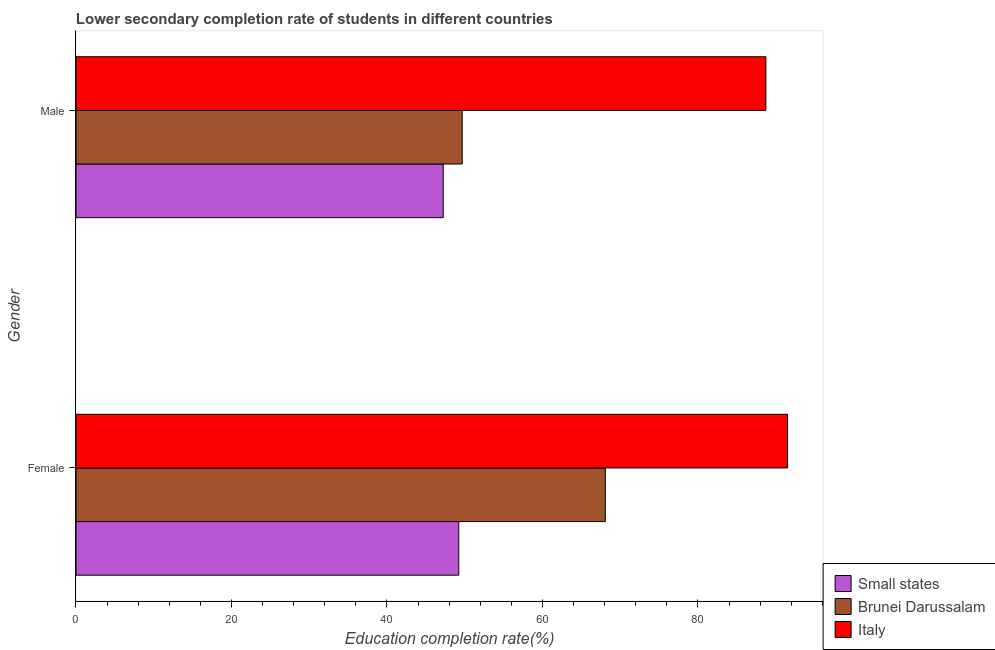How many different coloured bars are there?
Your answer should be very brief. 3. How many groups of bars are there?
Ensure brevity in your answer.  2. Are the number of bars on each tick of the Y-axis equal?
Provide a succinct answer. Yes. What is the education completion rate of female students in Italy?
Provide a short and direct response. 91.52. Across all countries, what is the maximum education completion rate of male students?
Your answer should be compact. 88.74. Across all countries, what is the minimum education completion rate of female students?
Your answer should be very brief. 49.23. In which country was the education completion rate of male students maximum?
Give a very brief answer. Italy. In which country was the education completion rate of female students minimum?
Your answer should be compact. Small states. What is the total education completion rate of female students in the graph?
Provide a succinct answer. 208.84. What is the difference between the education completion rate of male students in Brunei Darussalam and that in Small states?
Provide a short and direct response. 2.44. What is the difference between the education completion rate of male students in Italy and the education completion rate of female students in Small states?
Your answer should be compact. 39.5. What is the average education completion rate of male students per country?
Provide a succinct answer. 61.88. What is the difference between the education completion rate of male students and education completion rate of female students in Brunei Darussalam?
Your response must be concise. -18.41. What is the ratio of the education completion rate of male students in Italy to that in Brunei Darussalam?
Provide a short and direct response. 1.79. In how many countries, is the education completion rate of female students greater than the average education completion rate of female students taken over all countries?
Offer a very short reply. 1. What does the 2nd bar from the top in Male represents?
Offer a very short reply. Brunei Darussalam. What does the 3rd bar from the bottom in Male represents?
Provide a succinct answer. Italy. Are all the bars in the graph horizontal?
Your response must be concise. Yes. How many countries are there in the graph?
Make the answer very short. 3. Does the graph contain any zero values?
Ensure brevity in your answer.  No. Does the graph contain grids?
Ensure brevity in your answer.  No. How many legend labels are there?
Offer a terse response. 3. How are the legend labels stacked?
Make the answer very short. Vertical. What is the title of the graph?
Your answer should be very brief. Lower secondary completion rate of students in different countries. Does "Burundi" appear as one of the legend labels in the graph?
Offer a very short reply. No. What is the label or title of the X-axis?
Your answer should be compact. Education completion rate(%). What is the Education completion rate(%) of Small states in Female?
Provide a succinct answer. 49.23. What is the Education completion rate(%) of Brunei Darussalam in Female?
Keep it short and to the point. 68.08. What is the Education completion rate(%) in Italy in Female?
Your answer should be very brief. 91.52. What is the Education completion rate(%) of Small states in Male?
Offer a very short reply. 47.24. What is the Education completion rate(%) in Brunei Darussalam in Male?
Make the answer very short. 49.68. What is the Education completion rate(%) in Italy in Male?
Ensure brevity in your answer.  88.74. Across all Gender, what is the maximum Education completion rate(%) of Small states?
Offer a terse response. 49.23. Across all Gender, what is the maximum Education completion rate(%) in Brunei Darussalam?
Make the answer very short. 68.08. Across all Gender, what is the maximum Education completion rate(%) in Italy?
Your answer should be compact. 91.52. Across all Gender, what is the minimum Education completion rate(%) in Small states?
Your answer should be very brief. 47.24. Across all Gender, what is the minimum Education completion rate(%) in Brunei Darussalam?
Ensure brevity in your answer.  49.68. Across all Gender, what is the minimum Education completion rate(%) of Italy?
Offer a terse response. 88.74. What is the total Education completion rate(%) of Small states in the graph?
Make the answer very short. 96.47. What is the total Education completion rate(%) of Brunei Darussalam in the graph?
Offer a very short reply. 117.76. What is the total Education completion rate(%) of Italy in the graph?
Offer a terse response. 180.26. What is the difference between the Education completion rate(%) of Small states in Female and that in Male?
Provide a short and direct response. 2. What is the difference between the Education completion rate(%) of Brunei Darussalam in Female and that in Male?
Keep it short and to the point. 18.41. What is the difference between the Education completion rate(%) in Italy in Female and that in Male?
Keep it short and to the point. 2.78. What is the difference between the Education completion rate(%) in Small states in Female and the Education completion rate(%) in Brunei Darussalam in Male?
Provide a short and direct response. -0.44. What is the difference between the Education completion rate(%) of Small states in Female and the Education completion rate(%) of Italy in Male?
Ensure brevity in your answer.  -39.5. What is the difference between the Education completion rate(%) in Brunei Darussalam in Female and the Education completion rate(%) in Italy in Male?
Your answer should be compact. -20.65. What is the average Education completion rate(%) in Small states per Gender?
Ensure brevity in your answer.  48.24. What is the average Education completion rate(%) of Brunei Darussalam per Gender?
Provide a short and direct response. 58.88. What is the average Education completion rate(%) in Italy per Gender?
Make the answer very short. 90.13. What is the difference between the Education completion rate(%) in Small states and Education completion rate(%) in Brunei Darussalam in Female?
Your response must be concise. -18.85. What is the difference between the Education completion rate(%) in Small states and Education completion rate(%) in Italy in Female?
Offer a very short reply. -42.29. What is the difference between the Education completion rate(%) in Brunei Darussalam and Education completion rate(%) in Italy in Female?
Offer a very short reply. -23.44. What is the difference between the Education completion rate(%) in Small states and Education completion rate(%) in Brunei Darussalam in Male?
Offer a terse response. -2.44. What is the difference between the Education completion rate(%) of Small states and Education completion rate(%) of Italy in Male?
Your answer should be very brief. -41.5. What is the difference between the Education completion rate(%) in Brunei Darussalam and Education completion rate(%) in Italy in Male?
Offer a terse response. -39.06. What is the ratio of the Education completion rate(%) of Small states in Female to that in Male?
Keep it short and to the point. 1.04. What is the ratio of the Education completion rate(%) of Brunei Darussalam in Female to that in Male?
Offer a very short reply. 1.37. What is the ratio of the Education completion rate(%) in Italy in Female to that in Male?
Ensure brevity in your answer.  1.03. What is the difference between the highest and the second highest Education completion rate(%) of Small states?
Offer a terse response. 2. What is the difference between the highest and the second highest Education completion rate(%) in Brunei Darussalam?
Offer a very short reply. 18.41. What is the difference between the highest and the second highest Education completion rate(%) of Italy?
Keep it short and to the point. 2.78. What is the difference between the highest and the lowest Education completion rate(%) in Small states?
Your response must be concise. 2. What is the difference between the highest and the lowest Education completion rate(%) of Brunei Darussalam?
Your response must be concise. 18.41. What is the difference between the highest and the lowest Education completion rate(%) of Italy?
Give a very brief answer. 2.78. 